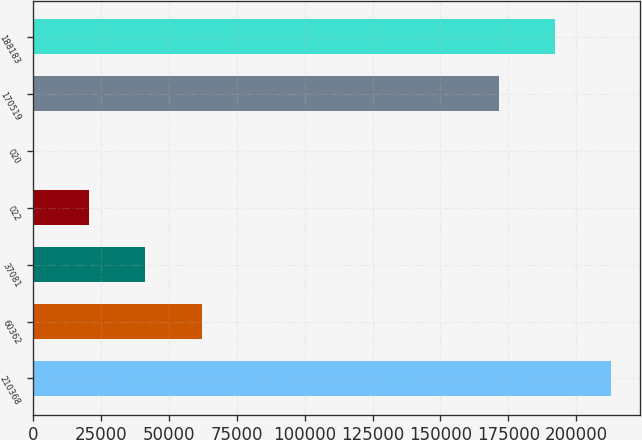Convert chart. <chart><loc_0><loc_0><loc_500><loc_500><bar_chart><fcel>210368<fcel>60362<fcel>37081<fcel>022<fcel>020<fcel>170519<fcel>188183<nl><fcel>212986<fcel>61987<fcel>41300.1<fcel>20650.2<fcel>0.18<fcel>171686<fcel>192336<nl></chart> 